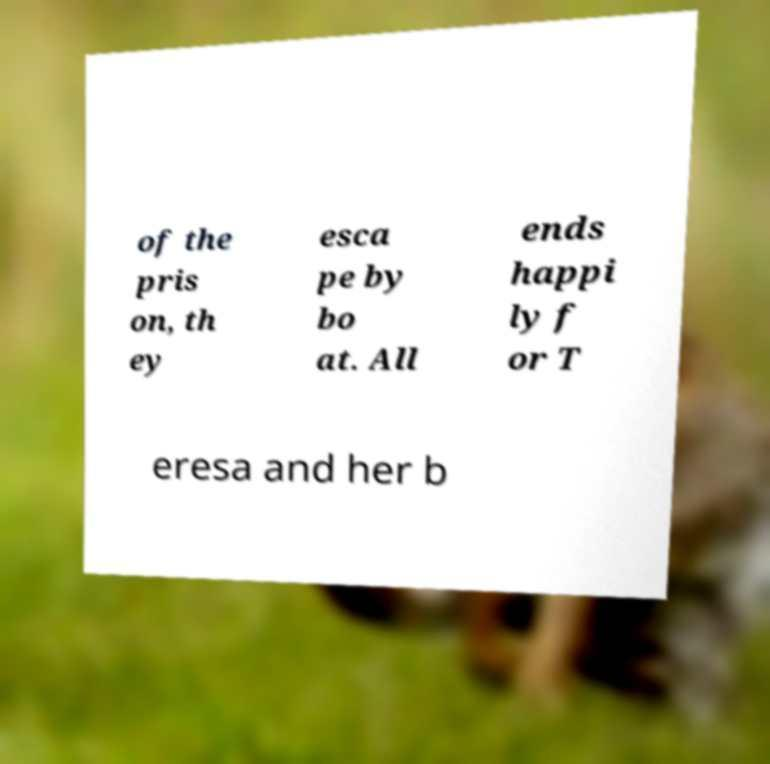What messages or text are displayed in this image? I need them in a readable, typed format. of the pris on, th ey esca pe by bo at. All ends happi ly f or T eresa and her b 